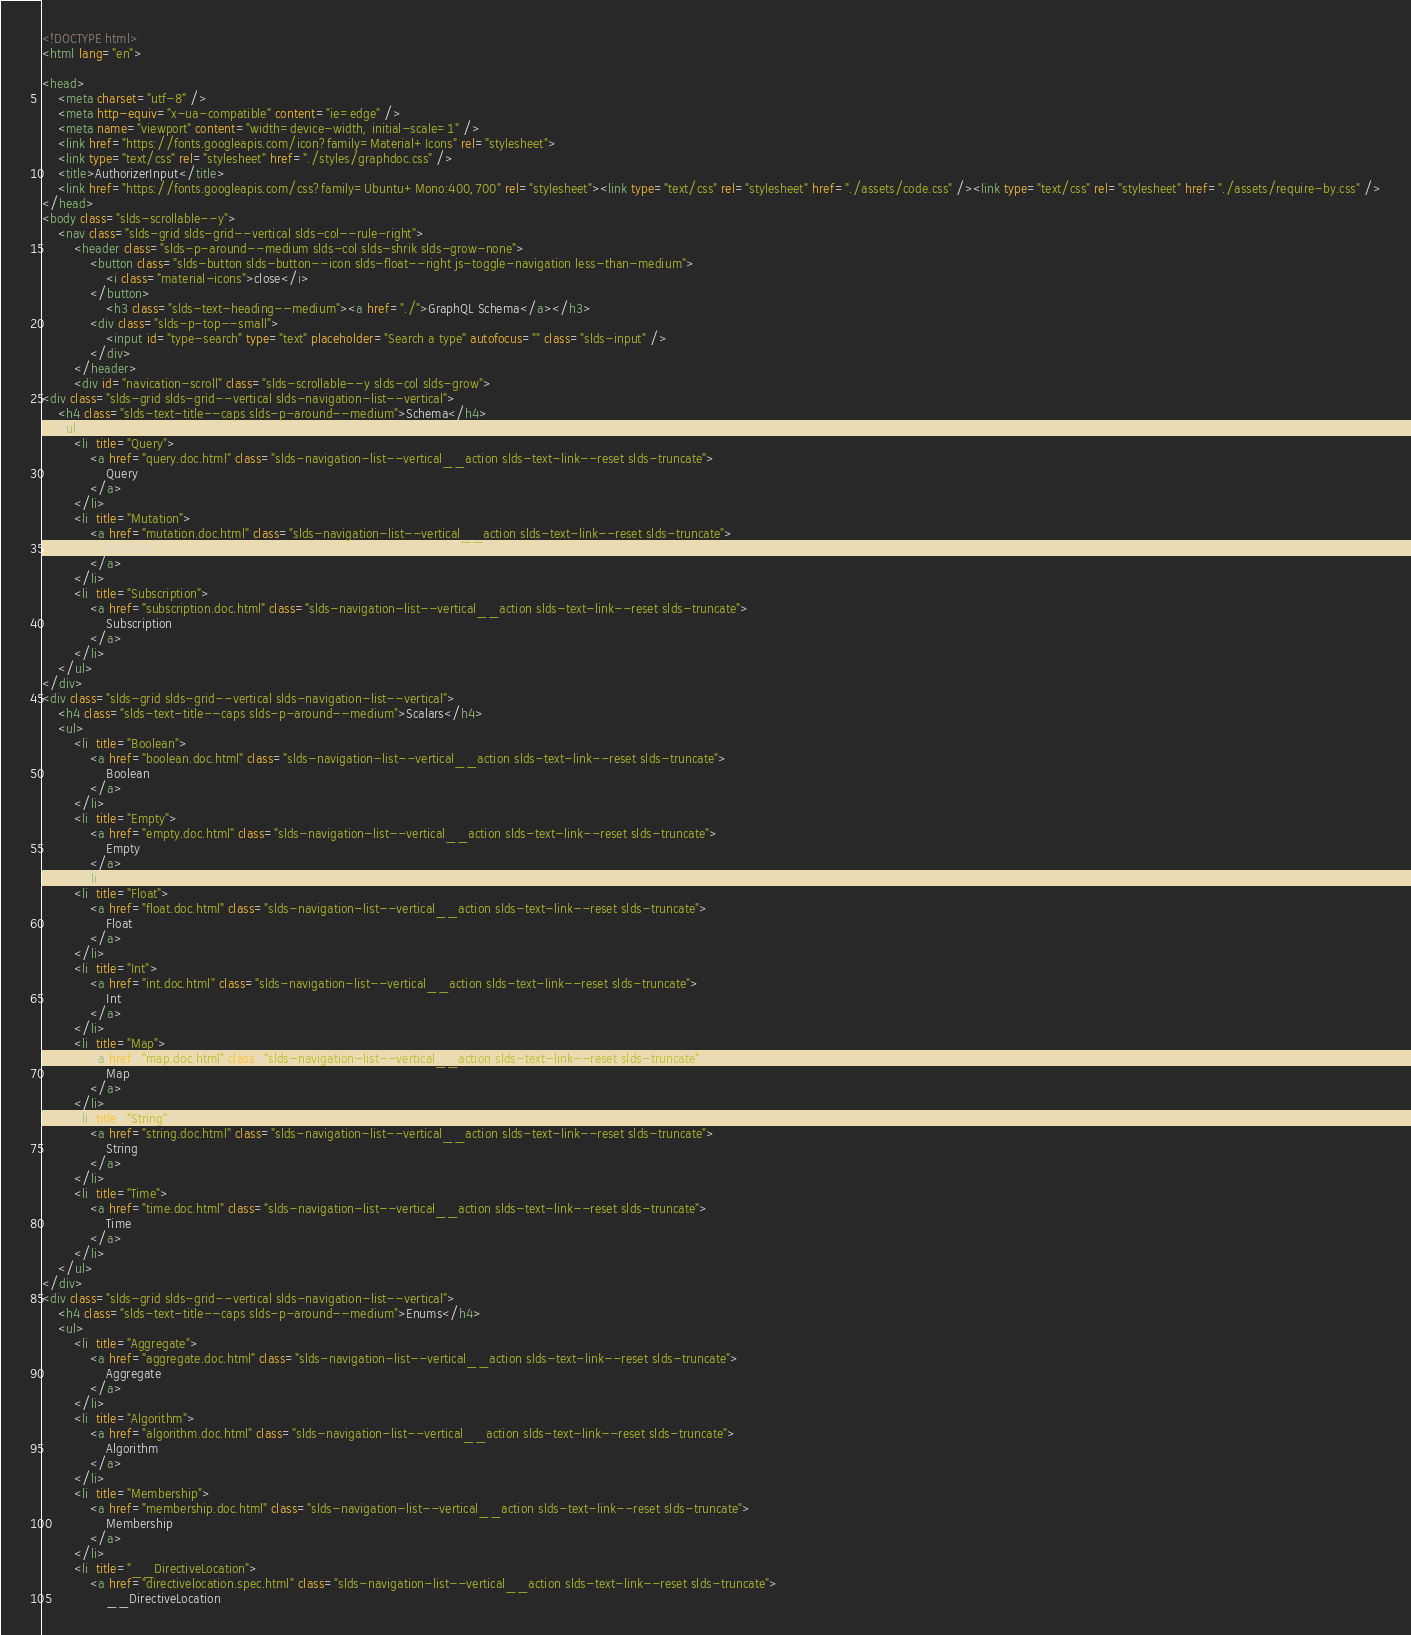<code> <loc_0><loc_0><loc_500><loc_500><_HTML_><!DOCTYPE html>
<html lang="en">

<head>
    <meta charset="utf-8" />
    <meta http-equiv="x-ua-compatible" content="ie=edge" />
    <meta name="viewport" content="width=device-width, initial-scale=1" />
    <link href="https://fonts.googleapis.com/icon?family=Material+Icons" rel="stylesheet">
    <link type="text/css" rel="stylesheet" href="./styles/graphdoc.css" />
    <title>AuthorizerInput</title>
    <link href="https://fonts.googleapis.com/css?family=Ubuntu+Mono:400,700" rel="stylesheet"><link type="text/css" rel="stylesheet" href="./assets/code.css" /><link type="text/css" rel="stylesheet" href="./assets/require-by.css" />
</head>
<body class="slds-scrollable--y">
    <nav class="slds-grid slds-grid--vertical slds-col--rule-right">
        <header class="slds-p-around--medium slds-col slds-shrik slds-grow-none">
            <button class="slds-button slds-button--icon slds-float--right js-toggle-navigation less-than-medium">
                <i class="material-icons">close</i>
            </button>
                <h3 class="slds-text-heading--medium"><a href="./">GraphQL Schema</a></h3>
            <div class="slds-p-top--small">
                <input id="type-search" type="text" placeholder="Search a type" autofocus="" class="slds-input" />
            </div>
        </header>
        <div id="navication-scroll" class="slds-scrollable--y slds-col slds-grow">
<div class="slds-grid slds-grid--vertical slds-navigation-list--vertical">
    <h4 class="slds-text-title--caps slds-p-around--medium">Schema</h4>
    <ul>
        <li  title="Query">
            <a href="query.doc.html" class="slds-navigation-list--vertical__action slds-text-link--reset slds-truncate">
                Query
            </a>
        </li>
        <li  title="Mutation">
            <a href="mutation.doc.html" class="slds-navigation-list--vertical__action slds-text-link--reset slds-truncate">
                Mutation
            </a>
        </li>
        <li  title="Subscription">
            <a href="subscription.doc.html" class="slds-navigation-list--vertical__action slds-text-link--reset slds-truncate">
                Subscription
            </a>
        </li>
    </ul>
</div>
<div class="slds-grid slds-grid--vertical slds-navigation-list--vertical">
    <h4 class="slds-text-title--caps slds-p-around--medium">Scalars</h4>
    <ul>
        <li  title="Boolean">
            <a href="boolean.doc.html" class="slds-navigation-list--vertical__action slds-text-link--reset slds-truncate">
                Boolean
            </a>
        </li>
        <li  title="Empty">
            <a href="empty.doc.html" class="slds-navigation-list--vertical__action slds-text-link--reset slds-truncate">
                Empty
            </a>
        </li>
        <li  title="Float">
            <a href="float.doc.html" class="slds-navigation-list--vertical__action slds-text-link--reset slds-truncate">
                Float
            </a>
        </li>
        <li  title="Int">
            <a href="int.doc.html" class="slds-navigation-list--vertical__action slds-text-link--reset slds-truncate">
                Int
            </a>
        </li>
        <li  title="Map">
            <a href="map.doc.html" class="slds-navigation-list--vertical__action slds-text-link--reset slds-truncate">
                Map
            </a>
        </li>
        <li  title="String">
            <a href="string.doc.html" class="slds-navigation-list--vertical__action slds-text-link--reset slds-truncate">
                String
            </a>
        </li>
        <li  title="Time">
            <a href="time.doc.html" class="slds-navigation-list--vertical__action slds-text-link--reset slds-truncate">
                Time
            </a>
        </li>
    </ul>
</div>
<div class="slds-grid slds-grid--vertical slds-navigation-list--vertical">
    <h4 class="slds-text-title--caps slds-p-around--medium">Enums</h4>
    <ul>
        <li  title="Aggregate">
            <a href="aggregate.doc.html" class="slds-navigation-list--vertical__action slds-text-link--reset slds-truncate">
                Aggregate
            </a>
        </li>
        <li  title="Algorithm">
            <a href="algorithm.doc.html" class="slds-navigation-list--vertical__action slds-text-link--reset slds-truncate">
                Algorithm
            </a>
        </li>
        <li  title="Membership">
            <a href="membership.doc.html" class="slds-navigation-list--vertical__action slds-text-link--reset slds-truncate">
                Membership
            </a>
        </li>
        <li  title="__DirectiveLocation">
            <a href="directivelocation.spec.html" class="slds-navigation-list--vertical__action slds-text-link--reset slds-truncate">
                __DirectiveLocation</code> 